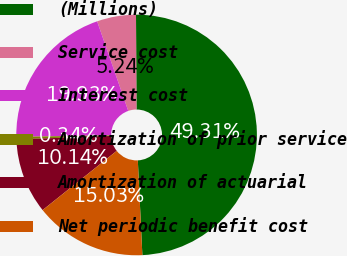Convert chart. <chart><loc_0><loc_0><loc_500><loc_500><pie_chart><fcel>(Millions)<fcel>Service cost<fcel>Interest cost<fcel>Amortization of prior service<fcel>Amortization of actuarial<fcel>Net periodic benefit cost<nl><fcel>49.31%<fcel>5.24%<fcel>19.93%<fcel>0.34%<fcel>10.14%<fcel>15.03%<nl></chart> 